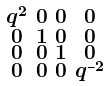<formula> <loc_0><loc_0><loc_500><loc_500>\begin{smallmatrix} q ^ { 2 } & 0 & 0 & 0 \\ 0 & 1 & 0 & 0 \\ 0 & 0 & 1 & 0 \\ 0 & 0 & 0 & q ^ { - 2 } \end{smallmatrix}</formula> 